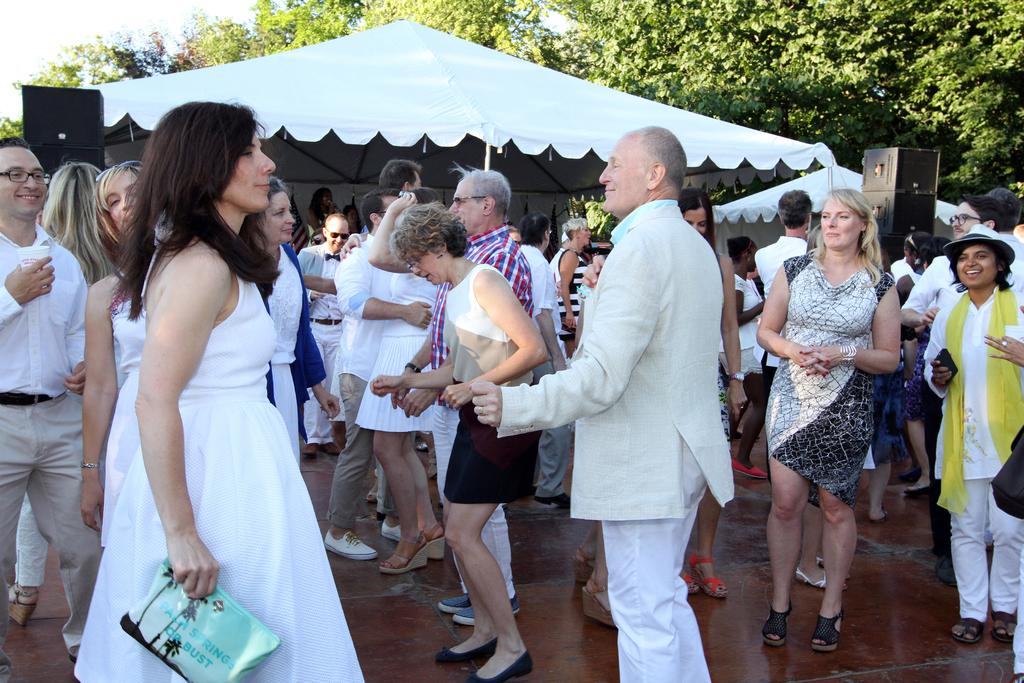How many people are in the image? There is a group of people standing in the image. Where are the people standing? The people are standing on the floor. What can be seen in the background of the image? There are canopy tents, speakers, trees, and the sky visible in the background of the image. Can you see a baby holding a potato in the image? There is no baby or potato present in the image. 